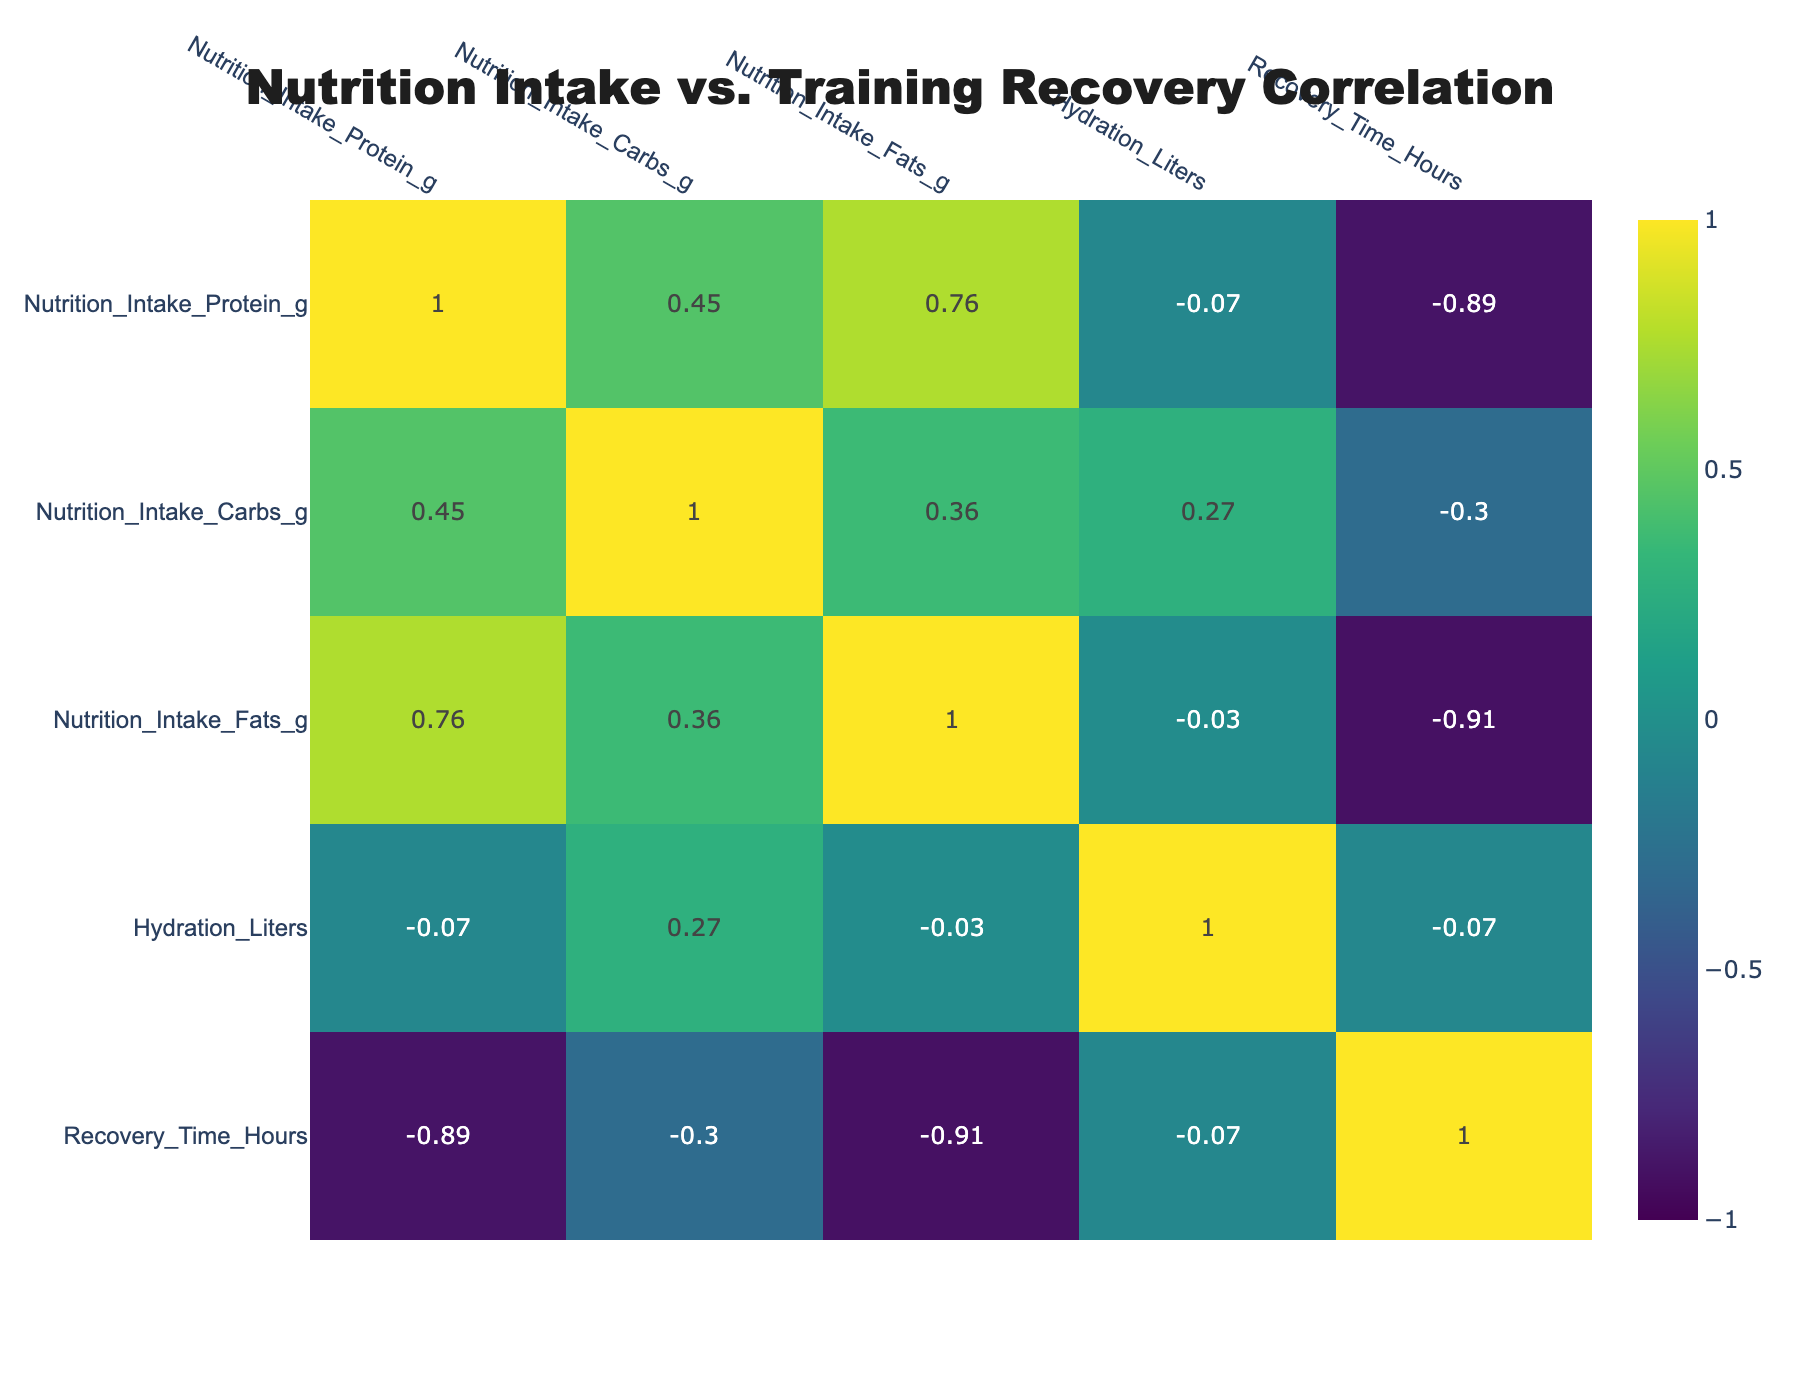What is the correlation between Nutrition Intake Protein (g) and Recovery Time (hours)? In the correlation table, we look at the intersection of the "Nutrition Intake Protein (g)" row and the "Recovery Time (hours)" column. The value there is -0.35, indicating a weak negative correlation. This means that higher protein intake does not significantly correlate with longer recovery times.
Answer: -0.35 Which nutrient intake has the highest positive correlation with recovery time? In the correlation table, we examine each nutrient's correlation with "Recovery Time (hours)." The correlation between "Nutrition Intake Carbs (g)" and "Recovery Time (hours)" is 0.55, which is the highest positive correlation amongst all listed nutrient intakes.
Answer: 0.55 What is the average recovery time based on the given nutritional data? To find the average recovery time, we sum all recovery times (24 + 20 + 28 + 22 + 21 + 26 + 19 + 27 =  197) and divide by the number of entries (8). So, 197/8 = 24.625 hours.
Answer: 24.625 Does hydration level have a negative correlation with recovery time? In the correlation table, the value at the intersection of "Hydration (Liters)" and "Recovery Time (hours)" is -0.53, indicating a negative correlation. Therefore, yes, increased hydration levels correlate with shorter recovery times.
Answer: Yes What is the difference in correlation between fats intake and recovery time compared to carbs intake? From the table, the correlation for "Nutrition Intake Fats (g)" with "Recovery Time (hours)" is -0.05, while for "Nutrition Intake Carbs (g)" it is 0.55. The difference is 0.55 - (-0.05) = 0.60, indicating carbs have a greater positive correlation than fats have a negative correlation.
Answer: 0.60 Is there a significant correlation between protein intake and carbs intake? In the correlation table, the correlation value between "Nutrition Intake Protein (g)" and "Nutrition Intake Carbs (g)" is 0.28, which is a weak positive correlation. This indicates there is indeed a correlation, though it is not significant.
Answer: Yes What would be the recovery time if protein intake is increased to an average level of 135 grams? To answer this, we note that the correlation between protein and recovery time is weak (-0.35). While we can't directly compute this, the data suggests that recovery times do not change much with small changes in protein intake due to its weak correlation. Thus, recovery time would likely remain around the average of 24.625 hours.
Answer: Approximately 24.625 hours Which correlates stronger with recovery time, hydration or protein intake? By comparing the correlation values from the table, hydration has a correlation of -0.53 with recovery time, while protein has -0.35. Since -0.53 is a stronger negative correlation than -0.35, hydration level correlates stronger with recovery time.
Answer: Hydration 